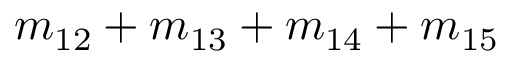<formula> <loc_0><loc_0><loc_500><loc_500>m _ { 1 2 } + m _ { 1 3 } + m _ { 1 4 } + m _ { 1 5 }</formula> 